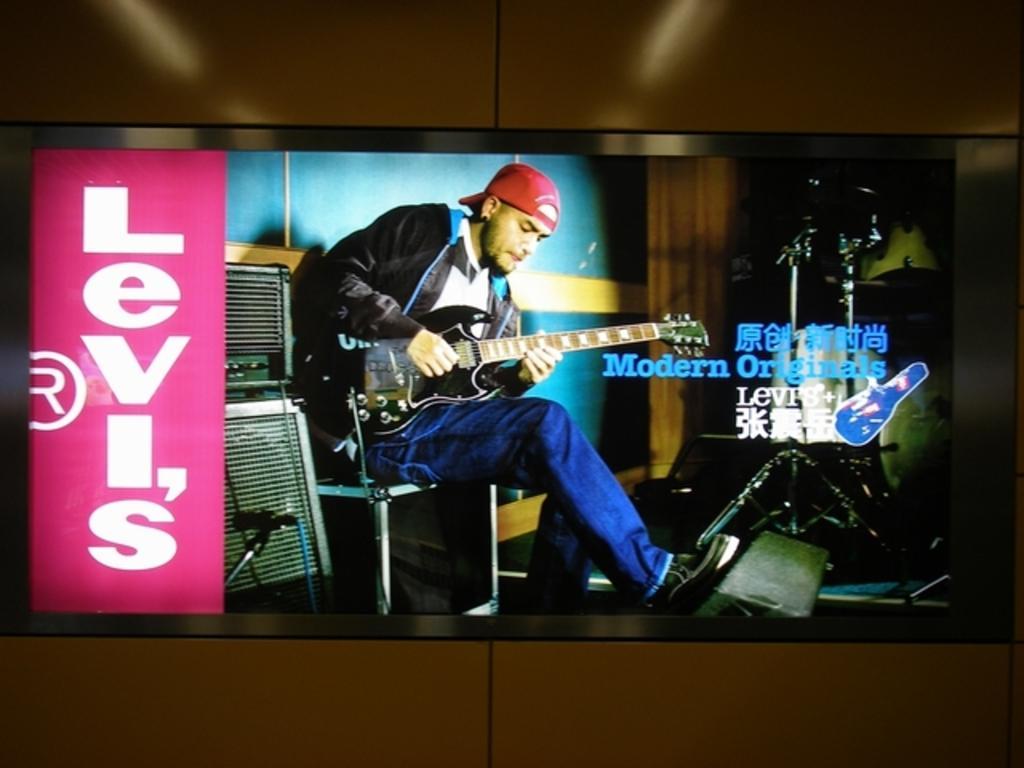Please provide a concise description of this image. We can see screen, in this screen there is a person sitting and playing guitar and we can see microphone and devices. We can see wall. 